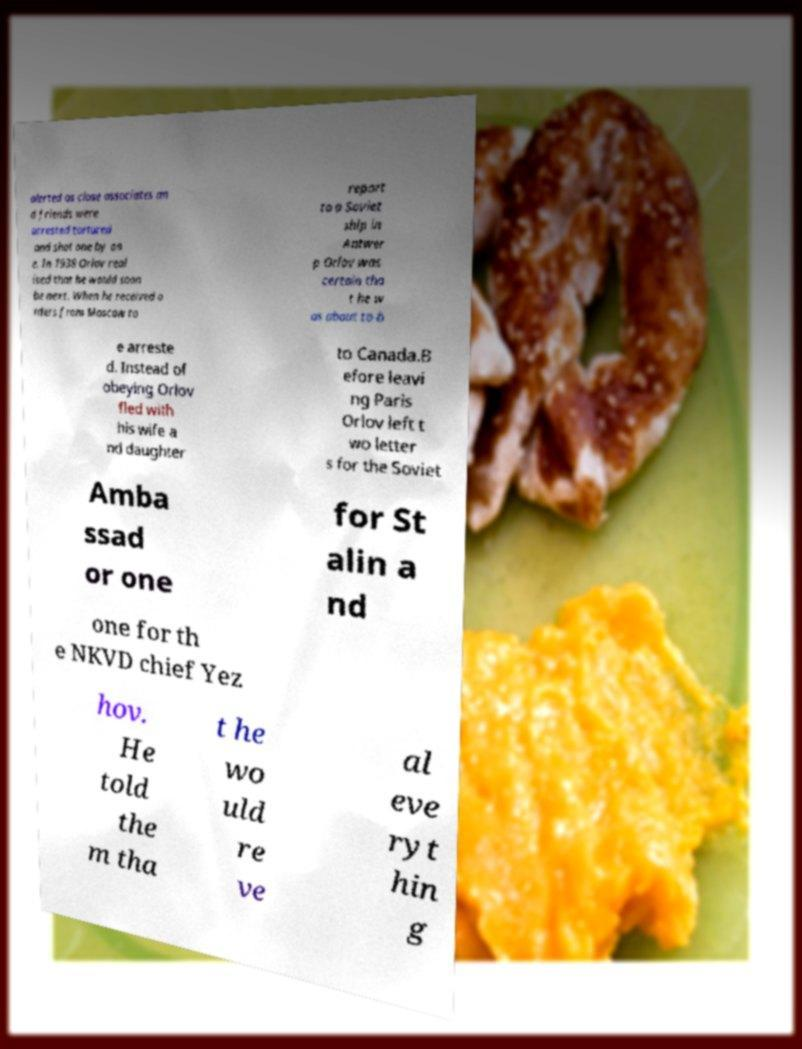Please identify and transcribe the text found in this image. alerted as close associates an d friends were arrested tortured and shot one by on e. In 1938 Orlov real ised that he would soon be next. When he received o rders from Moscow to report to a Soviet ship in Antwer p Orlov was certain tha t he w as about to b e arreste d. Instead of obeying Orlov fled with his wife a nd daughter to Canada.B efore leavi ng Paris Orlov left t wo letter s for the Soviet Amba ssad or one for St alin a nd one for th e NKVD chief Yez hov. He told the m tha t he wo uld re ve al eve ryt hin g 